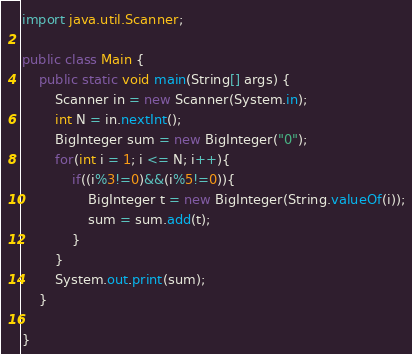Convert code to text. <code><loc_0><loc_0><loc_500><loc_500><_Java_>import java.util.Scanner;

public class Main {
    public static void main(String[] args) {
        Scanner in = new Scanner(System.in);
        int N = in.nextInt();
        BigInteger sum = new BigInteger("0");
        for(int i = 1; i <= N; i++){
            if((i%3!=0)&&(i%5!=0)){
                BigInteger t = new BigInteger(String.valueOf(i));
                sum = sum.add(t);
            }
        }
        System.out.print(sum);
    }

}
</code> 